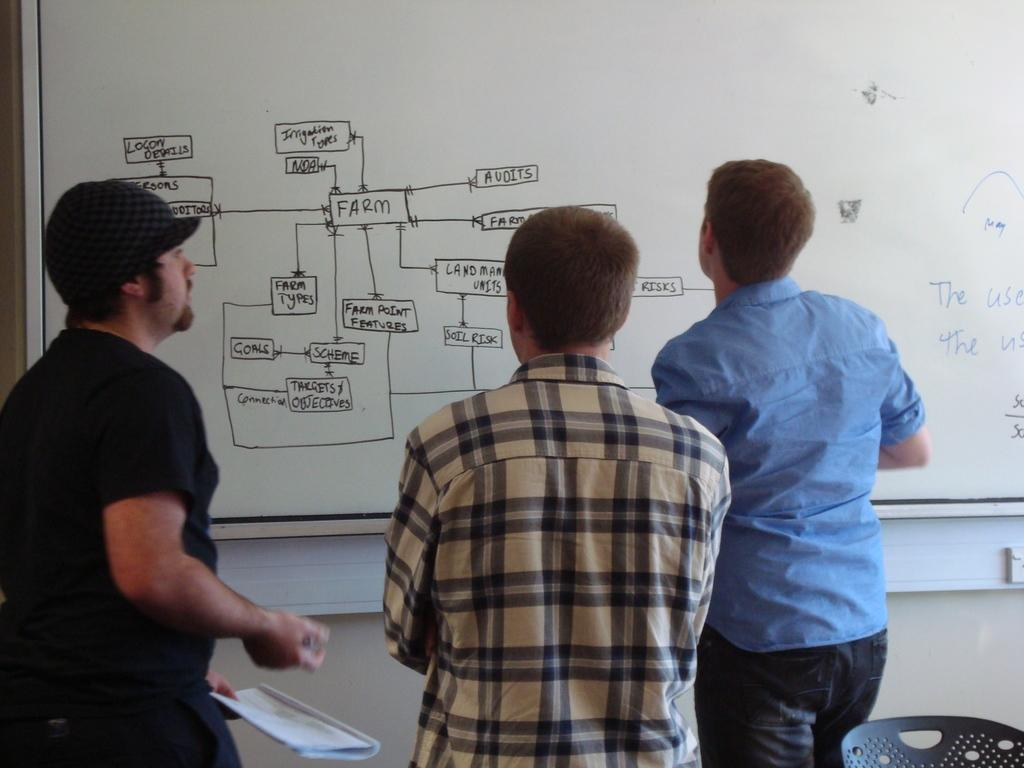Who or what can be seen in the image? There are people in the image. What is present in the background of the image? There is a whiteboard with text written on it in the background of the image. What type of pancake is being sneezed onto the whiteboard in the image? There is no pancake or sneezing present in the image; it only features people and a whiteboard with text. 